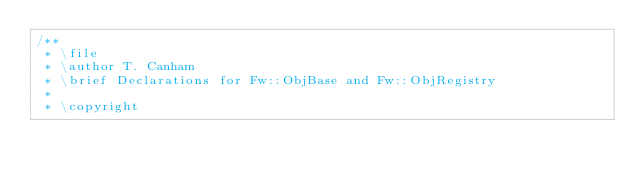Convert code to text. <code><loc_0><loc_0><loc_500><loc_500><_C++_>/**
 * \file
 * \author T. Canham
 * \brief Declarations for Fw::ObjBase and Fw::ObjRegistry
 *
 * \copyright</code> 